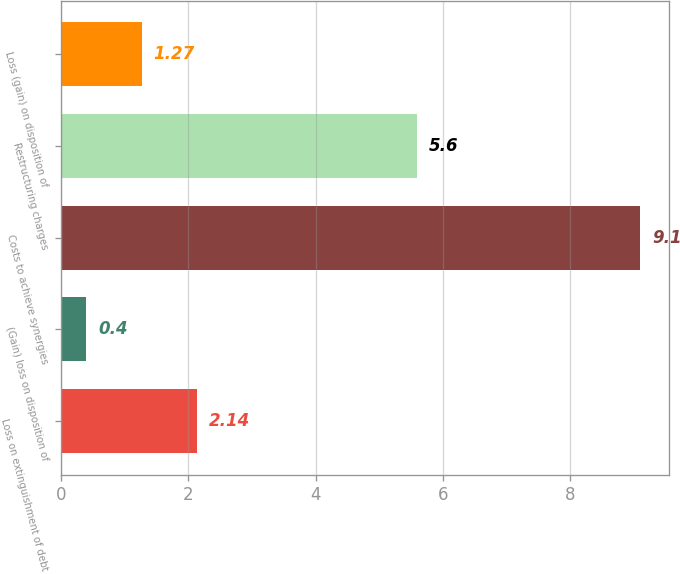Convert chart to OTSL. <chart><loc_0><loc_0><loc_500><loc_500><bar_chart><fcel>Loss on extinguishment of debt<fcel>(Gain) loss on disposition of<fcel>Costs to achieve synergies<fcel>Restructuring charges<fcel>Loss (gain) on disposition of<nl><fcel>2.14<fcel>0.4<fcel>9.1<fcel>5.6<fcel>1.27<nl></chart> 